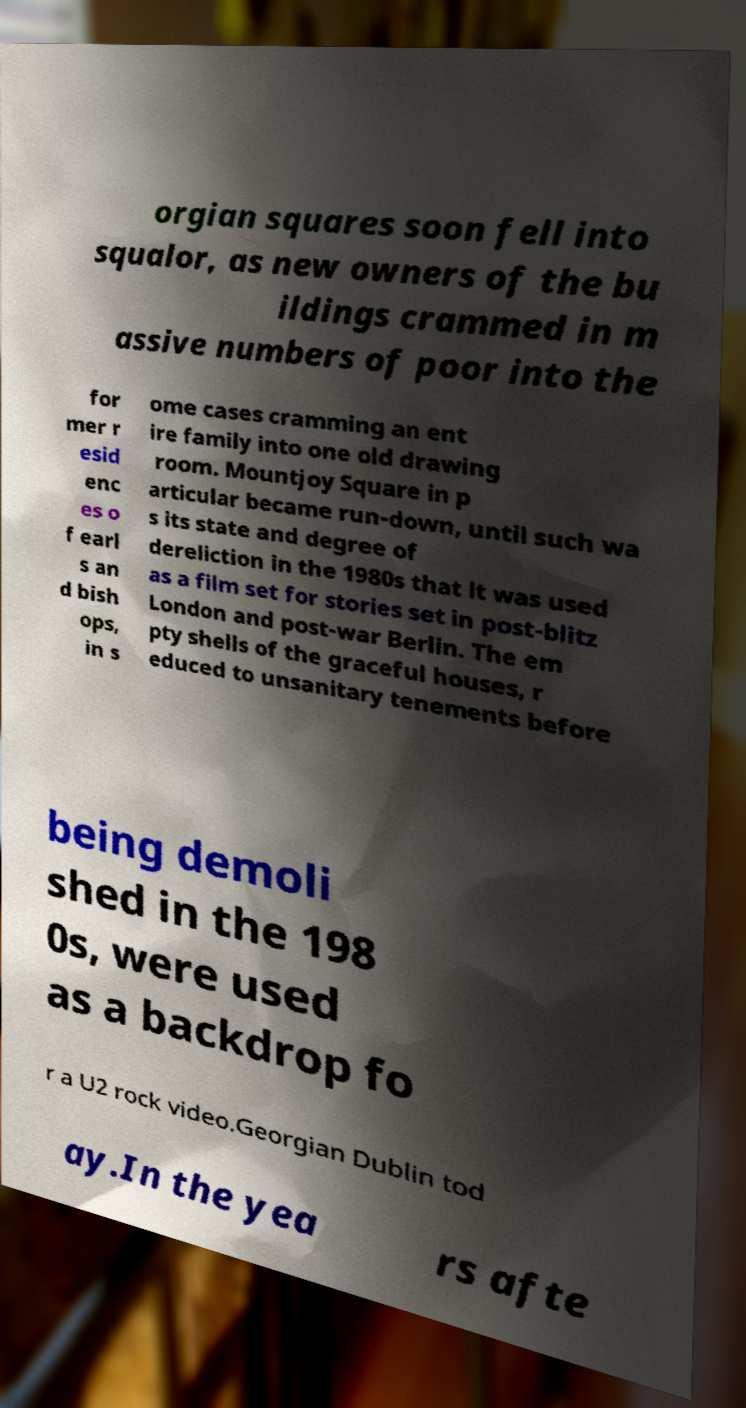There's text embedded in this image that I need extracted. Can you transcribe it verbatim? orgian squares soon fell into squalor, as new owners of the bu ildings crammed in m assive numbers of poor into the for mer r esid enc es o f earl s an d bish ops, in s ome cases cramming an ent ire family into one old drawing room. Mountjoy Square in p articular became run-down, until such wa s its state and degree of dereliction in the 1980s that it was used as a film set for stories set in post-blitz London and post-war Berlin. The em pty shells of the graceful houses, r educed to unsanitary tenements before being demoli shed in the 198 0s, were used as a backdrop fo r a U2 rock video.Georgian Dublin tod ay.In the yea rs afte 